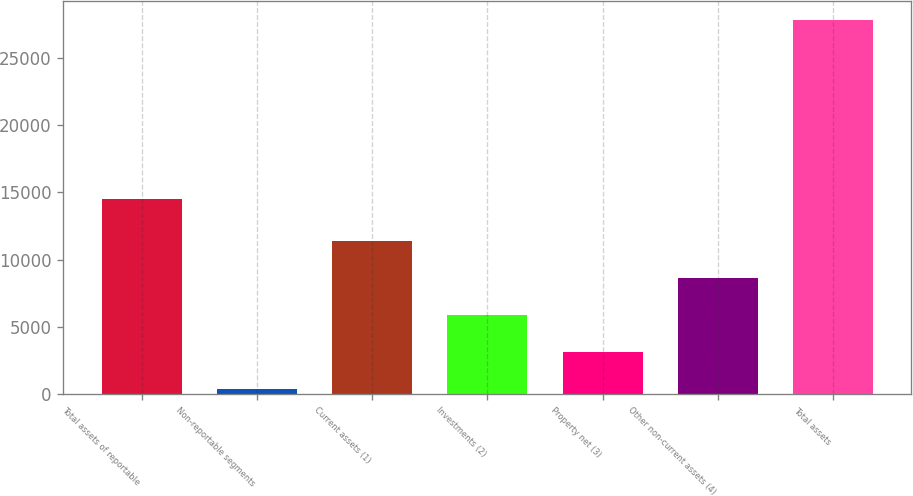Convert chart. <chart><loc_0><loc_0><loc_500><loc_500><bar_chart><fcel>Total assets of reportable<fcel>Non-reportable segments<fcel>Current assets (1)<fcel>Investments (2)<fcel>Property net (3)<fcel>Other non-current assets (4)<fcel>Total assets<nl><fcel>14495<fcel>396<fcel>11376.8<fcel>5886.4<fcel>3141.2<fcel>8631.6<fcel>27848<nl></chart> 